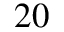Convert formula to latex. <formula><loc_0><loc_0><loc_500><loc_500>2 0</formula> 